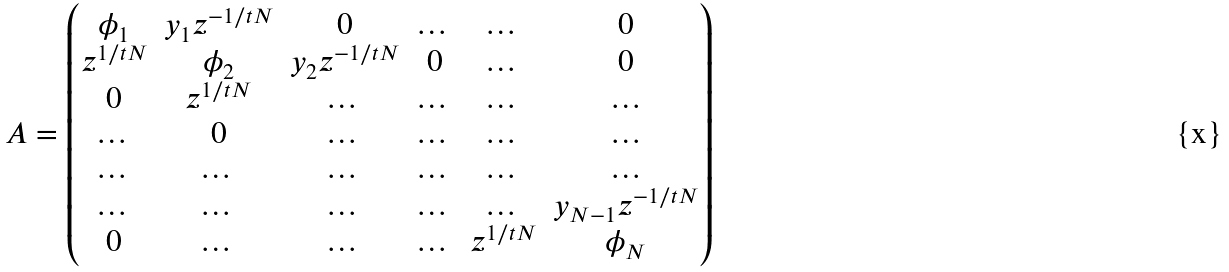Convert formula to latex. <formula><loc_0><loc_0><loc_500><loc_500>A = \begin{pmatrix} \phi _ { 1 } & y _ { 1 } z ^ { - 1 / t N } & 0 & \dots & \dots & 0 \\ z ^ { 1 / t N } & \phi _ { 2 } & y _ { 2 } z ^ { - 1 / t N } & 0 & \dots & 0 \\ 0 & z ^ { 1 / t N } & \dots & \dots & \dots & \dots \\ \dots & 0 & \dots & \dots & \dots & \dots \\ \dots & \dots & \dots & \dots & \dots & \dots \\ \dots & \dots & \dots & \dots & \dots & y _ { N - 1 } z ^ { - 1 / t N } \\ 0 & \dots & \dots & \dots & z ^ { 1 / t N } & \phi _ { N } \\ \end{pmatrix}</formula> 